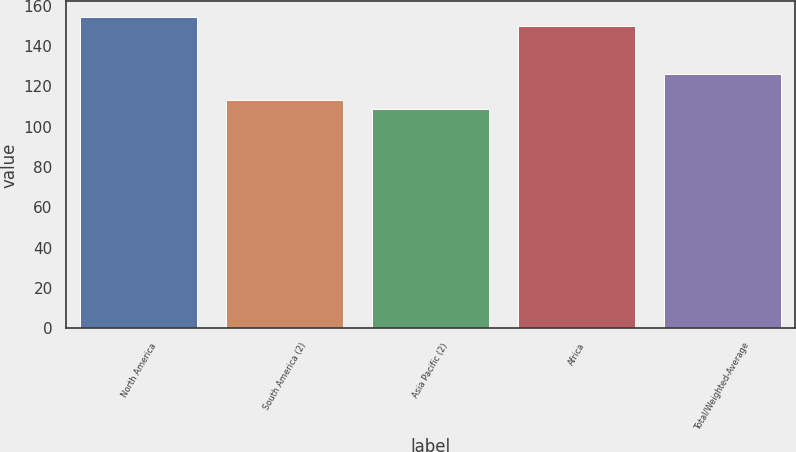<chart> <loc_0><loc_0><loc_500><loc_500><bar_chart><fcel>North America<fcel>South America (2)<fcel>Asia Pacific (2)<fcel>Africa<fcel>Total/Weighted-Average<nl><fcel>154.4<fcel>113.4<fcel>109<fcel>150<fcel>126<nl></chart> 